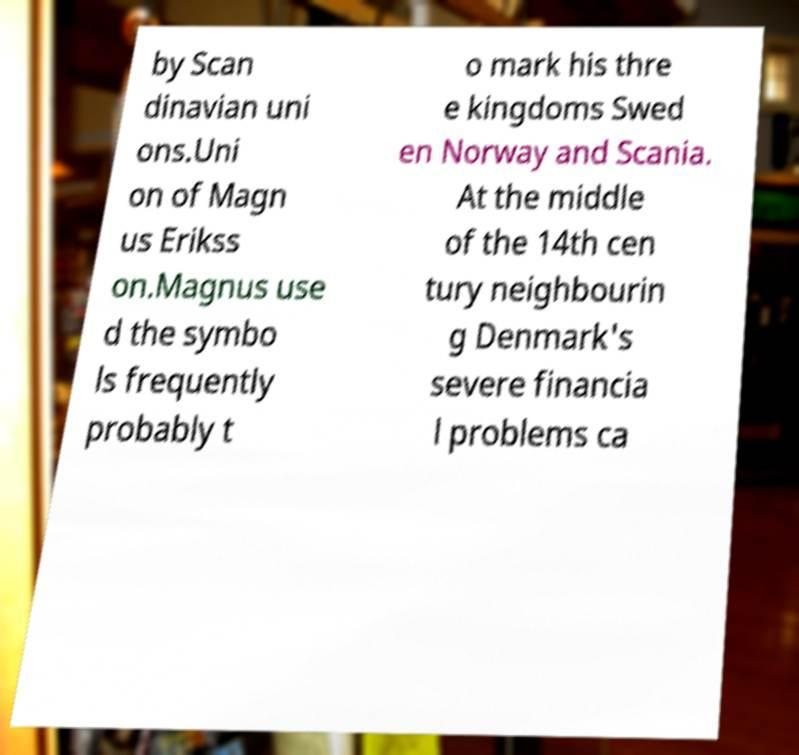There's text embedded in this image that I need extracted. Can you transcribe it verbatim? by Scan dinavian uni ons.Uni on of Magn us Erikss on.Magnus use d the symbo ls frequently probably t o mark his thre e kingdoms Swed en Norway and Scania. At the middle of the 14th cen tury neighbourin g Denmark's severe financia l problems ca 